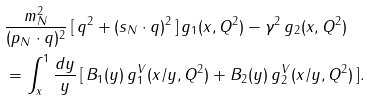<formula> <loc_0><loc_0><loc_500><loc_500>& \frac { m _ { N } ^ { 2 } } { ( p _ { N } \cdot q ) ^ { 2 } } \, [ \, q ^ { 2 } + ( s _ { N } \cdot q ) ^ { 2 } \, ] \, g _ { 1 } ( x , Q ^ { 2 } ) - \gamma ^ { 2 } \, g _ { 2 } ( x , Q ^ { 2 } ) \\ & = \int _ { x } ^ { 1 } \frac { d y } { y } \, [ \, B _ { 1 } ( y ) \, g _ { 1 } ^ { V } ( x / y , Q ^ { 2 } ) + B _ { 2 } ( y ) \, g _ { 2 } ^ { V } ( x / y , Q ^ { 2 } ) \, ] .</formula> 